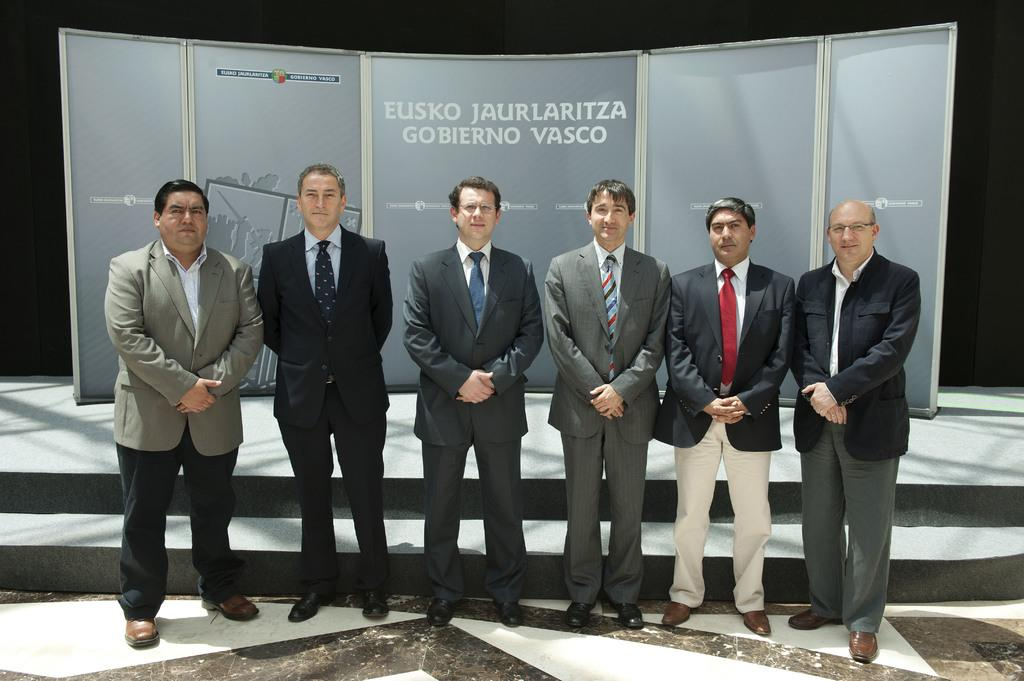What type of clothing can be seen on the men in the image? There are blazers and ties in the image. What type of footwear are the men wearing? There are shoes in the image. How many men are present in the image? There are six men standing in the image. What is the facial expression of the men? The men are smiling. What is the surface on which the men are standing? The men are standing on the floor. What can be seen in the background of the image? There are posters on a stage in the background, and the background is dark. What type of trees can be seen in the image? There are no trees present in the image. How much profit did the men make from their performance in the image? There is no information about profit or a performance in the image. 